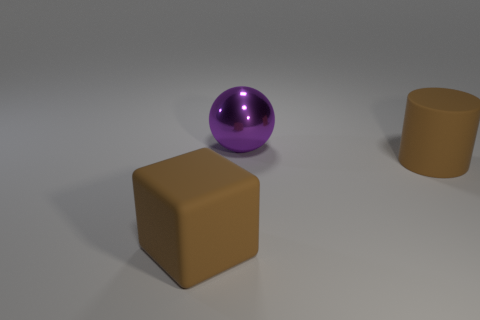There is a brown thing that is on the left side of the sphere; what size is it?
Offer a very short reply. Large. What number of other things are there of the same material as the purple thing
Make the answer very short. 0. There is a big brown object left of the metallic thing; are there any big brown things that are right of it?
Ensure brevity in your answer.  Yes. Is there anything else that is the same shape as the big metallic object?
Offer a very short reply. No. What size is the purple shiny object?
Make the answer very short. Large. Are there fewer purple spheres that are to the right of the big brown cylinder than big green cubes?
Your response must be concise. No. Do the large sphere and the thing in front of the brown rubber cylinder have the same material?
Keep it short and to the point. No. There is a large rubber object that is behind the large brown rubber thing to the left of the cylinder; are there any objects behind it?
Your answer should be very brief. Yes. Are there any other things that have the same size as the brown cube?
Make the answer very short. Yes. What color is the object that is the same material as the big brown block?
Offer a very short reply. Brown. 